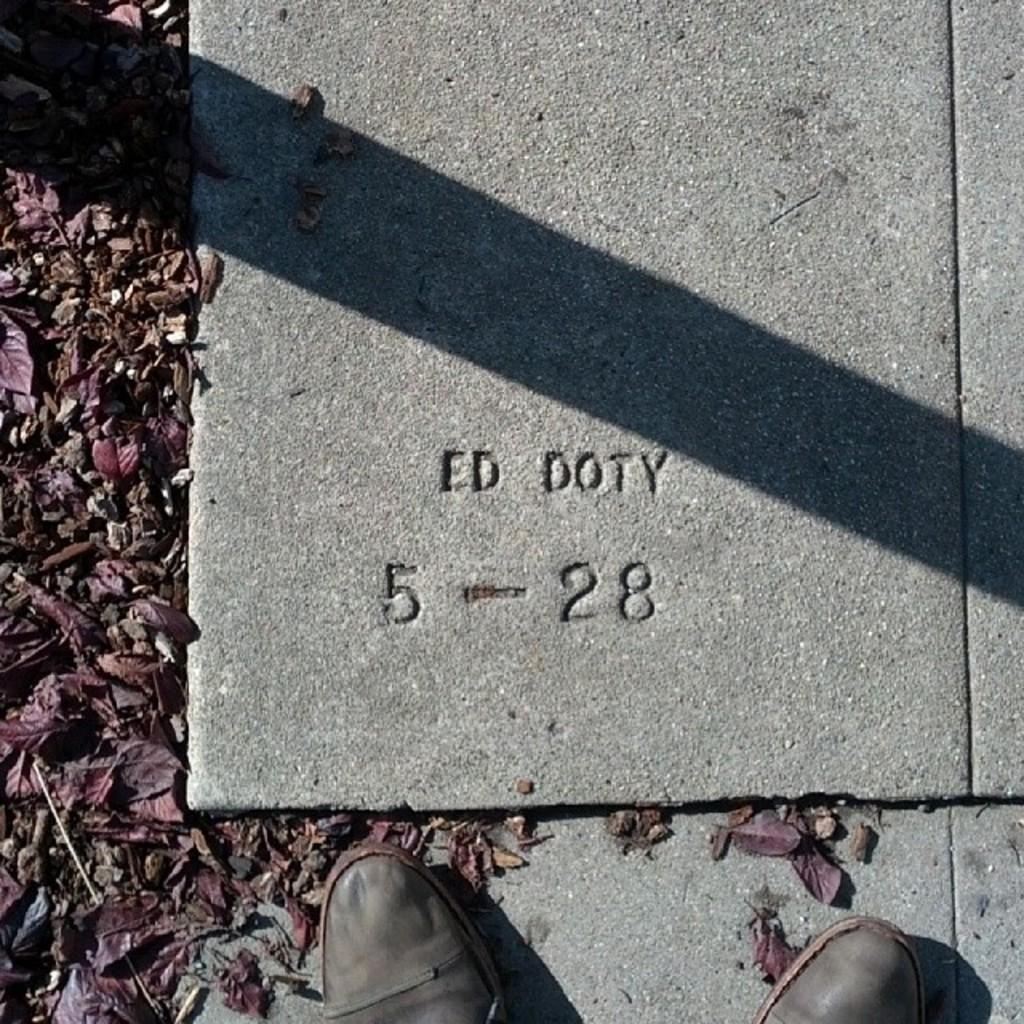Could you give a brief overview of what you see in this image? In this image we can see a pair of shoes, text on the tile and shredded leaves on the ground. 